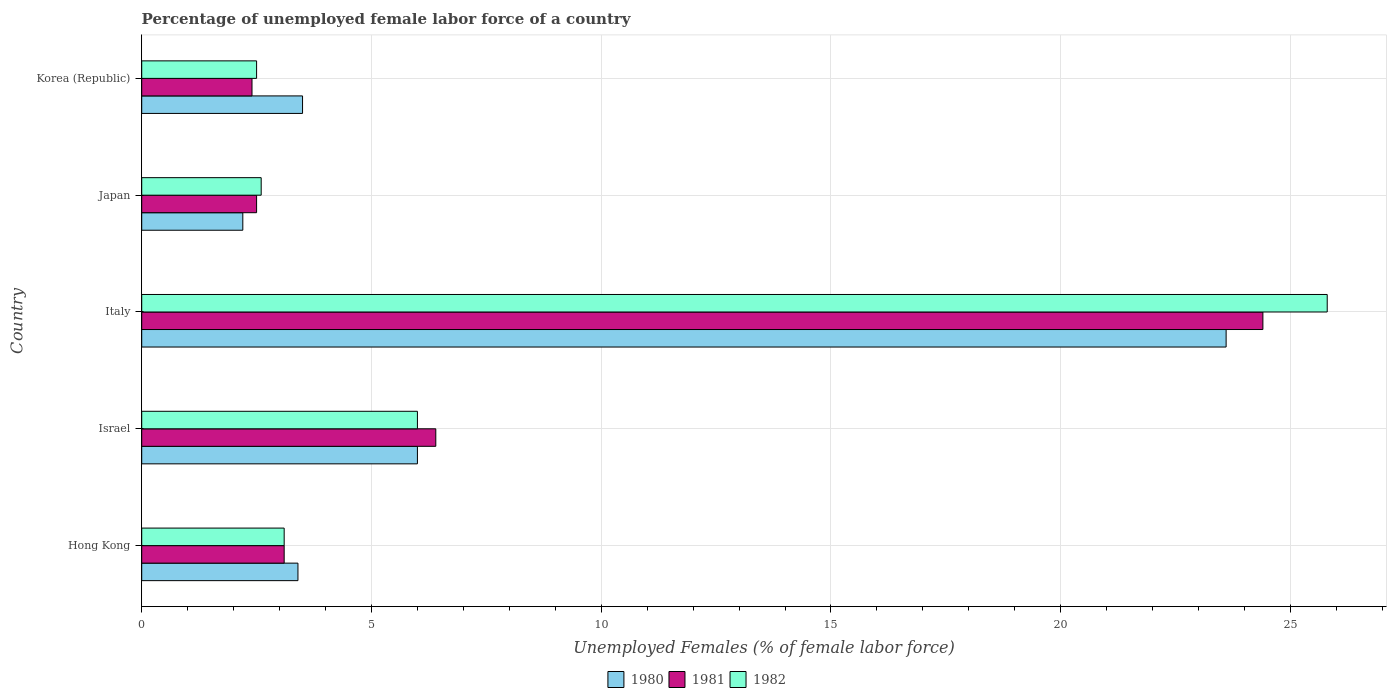How many different coloured bars are there?
Make the answer very short. 3. How many groups of bars are there?
Provide a succinct answer. 5. Are the number of bars per tick equal to the number of legend labels?
Ensure brevity in your answer.  Yes. In how many cases, is the number of bars for a given country not equal to the number of legend labels?
Your response must be concise. 0. What is the percentage of unemployed female labor force in 1981 in Hong Kong?
Offer a very short reply. 3.1. Across all countries, what is the maximum percentage of unemployed female labor force in 1981?
Provide a short and direct response. 24.4. Across all countries, what is the minimum percentage of unemployed female labor force in 1980?
Offer a very short reply. 2.2. In which country was the percentage of unemployed female labor force in 1980 maximum?
Ensure brevity in your answer.  Italy. What is the total percentage of unemployed female labor force in 1981 in the graph?
Provide a short and direct response. 38.8. What is the difference between the percentage of unemployed female labor force in 1981 in Hong Kong and that in Japan?
Keep it short and to the point. 0.6. What is the average percentage of unemployed female labor force in 1980 per country?
Ensure brevity in your answer.  7.74. What is the difference between the percentage of unemployed female labor force in 1982 and percentage of unemployed female labor force in 1980 in Italy?
Offer a very short reply. 2.2. In how many countries, is the percentage of unemployed female labor force in 1982 greater than 17 %?
Your response must be concise. 1. What is the ratio of the percentage of unemployed female labor force in 1980 in Hong Kong to that in Japan?
Make the answer very short. 1.55. Is the percentage of unemployed female labor force in 1981 in Hong Kong less than that in Korea (Republic)?
Offer a terse response. No. Is the difference between the percentage of unemployed female labor force in 1982 in Hong Kong and Korea (Republic) greater than the difference between the percentage of unemployed female labor force in 1980 in Hong Kong and Korea (Republic)?
Keep it short and to the point. Yes. What is the difference between the highest and the second highest percentage of unemployed female labor force in 1982?
Your response must be concise. 19.8. What is the difference between the highest and the lowest percentage of unemployed female labor force in 1980?
Make the answer very short. 21.4. In how many countries, is the percentage of unemployed female labor force in 1981 greater than the average percentage of unemployed female labor force in 1981 taken over all countries?
Provide a succinct answer. 1. Is it the case that in every country, the sum of the percentage of unemployed female labor force in 1980 and percentage of unemployed female labor force in 1982 is greater than the percentage of unemployed female labor force in 1981?
Offer a terse response. Yes. Are the values on the major ticks of X-axis written in scientific E-notation?
Keep it short and to the point. No. Does the graph contain grids?
Offer a very short reply. Yes. How are the legend labels stacked?
Give a very brief answer. Horizontal. What is the title of the graph?
Your answer should be compact. Percentage of unemployed female labor force of a country. Does "2015" appear as one of the legend labels in the graph?
Provide a short and direct response. No. What is the label or title of the X-axis?
Ensure brevity in your answer.  Unemployed Females (% of female labor force). What is the Unemployed Females (% of female labor force) of 1980 in Hong Kong?
Provide a short and direct response. 3.4. What is the Unemployed Females (% of female labor force) in 1981 in Hong Kong?
Provide a succinct answer. 3.1. What is the Unemployed Females (% of female labor force) in 1982 in Hong Kong?
Your response must be concise. 3.1. What is the Unemployed Females (% of female labor force) in 1980 in Israel?
Keep it short and to the point. 6. What is the Unemployed Females (% of female labor force) in 1981 in Israel?
Offer a very short reply. 6.4. What is the Unemployed Females (% of female labor force) of 1982 in Israel?
Keep it short and to the point. 6. What is the Unemployed Females (% of female labor force) in 1980 in Italy?
Ensure brevity in your answer.  23.6. What is the Unemployed Females (% of female labor force) of 1981 in Italy?
Your answer should be very brief. 24.4. What is the Unemployed Females (% of female labor force) of 1982 in Italy?
Provide a short and direct response. 25.8. What is the Unemployed Females (% of female labor force) in 1980 in Japan?
Provide a short and direct response. 2.2. What is the Unemployed Females (% of female labor force) of 1981 in Japan?
Your response must be concise. 2.5. What is the Unemployed Females (% of female labor force) of 1982 in Japan?
Your answer should be compact. 2.6. What is the Unemployed Females (% of female labor force) of 1981 in Korea (Republic)?
Give a very brief answer. 2.4. Across all countries, what is the maximum Unemployed Females (% of female labor force) in 1980?
Your answer should be compact. 23.6. Across all countries, what is the maximum Unemployed Females (% of female labor force) of 1981?
Your response must be concise. 24.4. Across all countries, what is the maximum Unemployed Females (% of female labor force) of 1982?
Keep it short and to the point. 25.8. Across all countries, what is the minimum Unemployed Females (% of female labor force) of 1980?
Ensure brevity in your answer.  2.2. Across all countries, what is the minimum Unemployed Females (% of female labor force) in 1981?
Offer a terse response. 2.4. What is the total Unemployed Females (% of female labor force) in 1980 in the graph?
Keep it short and to the point. 38.7. What is the total Unemployed Females (% of female labor force) in 1981 in the graph?
Provide a short and direct response. 38.8. What is the total Unemployed Females (% of female labor force) in 1982 in the graph?
Your answer should be compact. 40. What is the difference between the Unemployed Females (% of female labor force) in 1981 in Hong Kong and that in Israel?
Offer a very short reply. -3.3. What is the difference between the Unemployed Females (% of female labor force) in 1980 in Hong Kong and that in Italy?
Give a very brief answer. -20.2. What is the difference between the Unemployed Females (% of female labor force) in 1981 in Hong Kong and that in Italy?
Ensure brevity in your answer.  -21.3. What is the difference between the Unemployed Females (% of female labor force) in 1982 in Hong Kong and that in Italy?
Ensure brevity in your answer.  -22.7. What is the difference between the Unemployed Females (% of female labor force) in 1980 in Hong Kong and that in Korea (Republic)?
Offer a very short reply. -0.1. What is the difference between the Unemployed Females (% of female labor force) in 1981 in Hong Kong and that in Korea (Republic)?
Offer a very short reply. 0.7. What is the difference between the Unemployed Females (% of female labor force) of 1980 in Israel and that in Italy?
Provide a short and direct response. -17.6. What is the difference between the Unemployed Females (% of female labor force) of 1981 in Israel and that in Italy?
Keep it short and to the point. -18. What is the difference between the Unemployed Females (% of female labor force) of 1982 in Israel and that in Italy?
Give a very brief answer. -19.8. What is the difference between the Unemployed Females (% of female labor force) of 1981 in Israel and that in Japan?
Provide a short and direct response. 3.9. What is the difference between the Unemployed Females (% of female labor force) in 1982 in Israel and that in Japan?
Your answer should be compact. 3.4. What is the difference between the Unemployed Females (% of female labor force) of 1982 in Israel and that in Korea (Republic)?
Provide a short and direct response. 3.5. What is the difference between the Unemployed Females (% of female labor force) of 1980 in Italy and that in Japan?
Your answer should be very brief. 21.4. What is the difference between the Unemployed Females (% of female labor force) of 1981 in Italy and that in Japan?
Your response must be concise. 21.9. What is the difference between the Unemployed Females (% of female labor force) in 1982 in Italy and that in Japan?
Ensure brevity in your answer.  23.2. What is the difference between the Unemployed Females (% of female labor force) of 1980 in Italy and that in Korea (Republic)?
Make the answer very short. 20.1. What is the difference between the Unemployed Females (% of female labor force) of 1981 in Italy and that in Korea (Republic)?
Offer a terse response. 22. What is the difference between the Unemployed Females (% of female labor force) in 1982 in Italy and that in Korea (Republic)?
Your response must be concise. 23.3. What is the difference between the Unemployed Females (% of female labor force) in 1980 in Japan and that in Korea (Republic)?
Provide a succinct answer. -1.3. What is the difference between the Unemployed Females (% of female labor force) of 1982 in Japan and that in Korea (Republic)?
Offer a very short reply. 0.1. What is the difference between the Unemployed Females (% of female labor force) in 1980 in Hong Kong and the Unemployed Females (% of female labor force) in 1981 in Italy?
Ensure brevity in your answer.  -21. What is the difference between the Unemployed Females (% of female labor force) of 1980 in Hong Kong and the Unemployed Females (% of female labor force) of 1982 in Italy?
Your answer should be compact. -22.4. What is the difference between the Unemployed Females (% of female labor force) of 1981 in Hong Kong and the Unemployed Females (% of female labor force) of 1982 in Italy?
Offer a very short reply. -22.7. What is the difference between the Unemployed Females (% of female labor force) in 1980 in Hong Kong and the Unemployed Females (% of female labor force) in 1981 in Japan?
Offer a very short reply. 0.9. What is the difference between the Unemployed Females (% of female labor force) in 1980 in Hong Kong and the Unemployed Females (% of female labor force) in 1982 in Korea (Republic)?
Keep it short and to the point. 0.9. What is the difference between the Unemployed Females (% of female labor force) in 1980 in Israel and the Unemployed Females (% of female labor force) in 1981 in Italy?
Your response must be concise. -18.4. What is the difference between the Unemployed Females (% of female labor force) of 1980 in Israel and the Unemployed Females (% of female labor force) of 1982 in Italy?
Ensure brevity in your answer.  -19.8. What is the difference between the Unemployed Females (% of female labor force) in 1981 in Israel and the Unemployed Females (% of female labor force) in 1982 in Italy?
Your response must be concise. -19.4. What is the difference between the Unemployed Females (% of female labor force) in 1981 in Israel and the Unemployed Females (% of female labor force) in 1982 in Korea (Republic)?
Make the answer very short. 3.9. What is the difference between the Unemployed Females (% of female labor force) in 1980 in Italy and the Unemployed Females (% of female labor force) in 1981 in Japan?
Ensure brevity in your answer.  21.1. What is the difference between the Unemployed Females (% of female labor force) in 1980 in Italy and the Unemployed Females (% of female labor force) in 1982 in Japan?
Your answer should be compact. 21. What is the difference between the Unemployed Females (% of female labor force) of 1981 in Italy and the Unemployed Females (% of female labor force) of 1982 in Japan?
Offer a terse response. 21.8. What is the difference between the Unemployed Females (% of female labor force) of 1980 in Italy and the Unemployed Females (% of female labor force) of 1981 in Korea (Republic)?
Provide a succinct answer. 21.2. What is the difference between the Unemployed Females (% of female labor force) in 1980 in Italy and the Unemployed Females (% of female labor force) in 1982 in Korea (Republic)?
Your answer should be very brief. 21.1. What is the difference between the Unemployed Females (% of female labor force) of 1981 in Italy and the Unemployed Females (% of female labor force) of 1982 in Korea (Republic)?
Provide a short and direct response. 21.9. What is the difference between the Unemployed Females (% of female labor force) of 1980 in Japan and the Unemployed Females (% of female labor force) of 1981 in Korea (Republic)?
Provide a succinct answer. -0.2. What is the difference between the Unemployed Females (% of female labor force) of 1981 in Japan and the Unemployed Females (% of female labor force) of 1982 in Korea (Republic)?
Your answer should be compact. 0. What is the average Unemployed Females (% of female labor force) in 1980 per country?
Offer a very short reply. 7.74. What is the average Unemployed Females (% of female labor force) in 1981 per country?
Keep it short and to the point. 7.76. What is the average Unemployed Females (% of female labor force) in 1982 per country?
Provide a succinct answer. 8. What is the difference between the Unemployed Females (% of female labor force) in 1981 and Unemployed Females (% of female labor force) in 1982 in Hong Kong?
Make the answer very short. 0. What is the difference between the Unemployed Females (% of female labor force) in 1980 and Unemployed Females (% of female labor force) in 1982 in Israel?
Offer a terse response. 0. What is the difference between the Unemployed Females (% of female labor force) of 1981 and Unemployed Females (% of female labor force) of 1982 in Israel?
Your answer should be very brief. 0.4. What is the difference between the Unemployed Females (% of female labor force) in 1980 and Unemployed Females (% of female labor force) in 1981 in Italy?
Your response must be concise. -0.8. What is the difference between the Unemployed Females (% of female labor force) of 1981 and Unemployed Females (% of female labor force) of 1982 in Italy?
Provide a succinct answer. -1.4. What is the difference between the Unemployed Females (% of female labor force) of 1980 and Unemployed Females (% of female labor force) of 1981 in Japan?
Make the answer very short. -0.3. What is the difference between the Unemployed Females (% of female labor force) in 1980 and Unemployed Females (% of female labor force) in 1981 in Korea (Republic)?
Offer a terse response. 1.1. What is the difference between the Unemployed Females (% of female labor force) of 1980 and Unemployed Females (% of female labor force) of 1982 in Korea (Republic)?
Keep it short and to the point. 1. What is the difference between the Unemployed Females (% of female labor force) of 1981 and Unemployed Females (% of female labor force) of 1982 in Korea (Republic)?
Your response must be concise. -0.1. What is the ratio of the Unemployed Females (% of female labor force) of 1980 in Hong Kong to that in Israel?
Keep it short and to the point. 0.57. What is the ratio of the Unemployed Females (% of female labor force) in 1981 in Hong Kong to that in Israel?
Your answer should be very brief. 0.48. What is the ratio of the Unemployed Females (% of female labor force) in 1982 in Hong Kong to that in Israel?
Offer a very short reply. 0.52. What is the ratio of the Unemployed Females (% of female labor force) in 1980 in Hong Kong to that in Italy?
Give a very brief answer. 0.14. What is the ratio of the Unemployed Females (% of female labor force) in 1981 in Hong Kong to that in Italy?
Offer a very short reply. 0.13. What is the ratio of the Unemployed Females (% of female labor force) in 1982 in Hong Kong to that in Italy?
Ensure brevity in your answer.  0.12. What is the ratio of the Unemployed Females (% of female labor force) in 1980 in Hong Kong to that in Japan?
Ensure brevity in your answer.  1.55. What is the ratio of the Unemployed Females (% of female labor force) of 1981 in Hong Kong to that in Japan?
Make the answer very short. 1.24. What is the ratio of the Unemployed Females (% of female labor force) of 1982 in Hong Kong to that in Japan?
Your answer should be very brief. 1.19. What is the ratio of the Unemployed Females (% of female labor force) of 1980 in Hong Kong to that in Korea (Republic)?
Your response must be concise. 0.97. What is the ratio of the Unemployed Females (% of female labor force) in 1981 in Hong Kong to that in Korea (Republic)?
Keep it short and to the point. 1.29. What is the ratio of the Unemployed Females (% of female labor force) of 1982 in Hong Kong to that in Korea (Republic)?
Ensure brevity in your answer.  1.24. What is the ratio of the Unemployed Females (% of female labor force) of 1980 in Israel to that in Italy?
Provide a succinct answer. 0.25. What is the ratio of the Unemployed Females (% of female labor force) of 1981 in Israel to that in Italy?
Keep it short and to the point. 0.26. What is the ratio of the Unemployed Females (% of female labor force) in 1982 in Israel to that in Italy?
Your response must be concise. 0.23. What is the ratio of the Unemployed Females (% of female labor force) of 1980 in Israel to that in Japan?
Your answer should be compact. 2.73. What is the ratio of the Unemployed Females (% of female labor force) of 1981 in Israel to that in Japan?
Make the answer very short. 2.56. What is the ratio of the Unemployed Females (% of female labor force) of 1982 in Israel to that in Japan?
Your answer should be very brief. 2.31. What is the ratio of the Unemployed Females (% of female labor force) in 1980 in Israel to that in Korea (Republic)?
Your answer should be very brief. 1.71. What is the ratio of the Unemployed Females (% of female labor force) of 1981 in Israel to that in Korea (Republic)?
Ensure brevity in your answer.  2.67. What is the ratio of the Unemployed Females (% of female labor force) of 1982 in Israel to that in Korea (Republic)?
Keep it short and to the point. 2.4. What is the ratio of the Unemployed Females (% of female labor force) in 1980 in Italy to that in Japan?
Your response must be concise. 10.73. What is the ratio of the Unemployed Females (% of female labor force) of 1981 in Italy to that in Japan?
Ensure brevity in your answer.  9.76. What is the ratio of the Unemployed Females (% of female labor force) in 1982 in Italy to that in Japan?
Make the answer very short. 9.92. What is the ratio of the Unemployed Females (% of female labor force) in 1980 in Italy to that in Korea (Republic)?
Provide a short and direct response. 6.74. What is the ratio of the Unemployed Females (% of female labor force) of 1981 in Italy to that in Korea (Republic)?
Your response must be concise. 10.17. What is the ratio of the Unemployed Females (% of female labor force) of 1982 in Italy to that in Korea (Republic)?
Your answer should be very brief. 10.32. What is the ratio of the Unemployed Females (% of female labor force) in 1980 in Japan to that in Korea (Republic)?
Offer a terse response. 0.63. What is the ratio of the Unemployed Females (% of female labor force) of 1981 in Japan to that in Korea (Republic)?
Provide a short and direct response. 1.04. What is the ratio of the Unemployed Females (% of female labor force) in 1982 in Japan to that in Korea (Republic)?
Your answer should be very brief. 1.04. What is the difference between the highest and the second highest Unemployed Females (% of female labor force) in 1982?
Give a very brief answer. 19.8. What is the difference between the highest and the lowest Unemployed Females (% of female labor force) of 1980?
Make the answer very short. 21.4. What is the difference between the highest and the lowest Unemployed Females (% of female labor force) of 1981?
Offer a terse response. 22. What is the difference between the highest and the lowest Unemployed Females (% of female labor force) in 1982?
Your response must be concise. 23.3. 